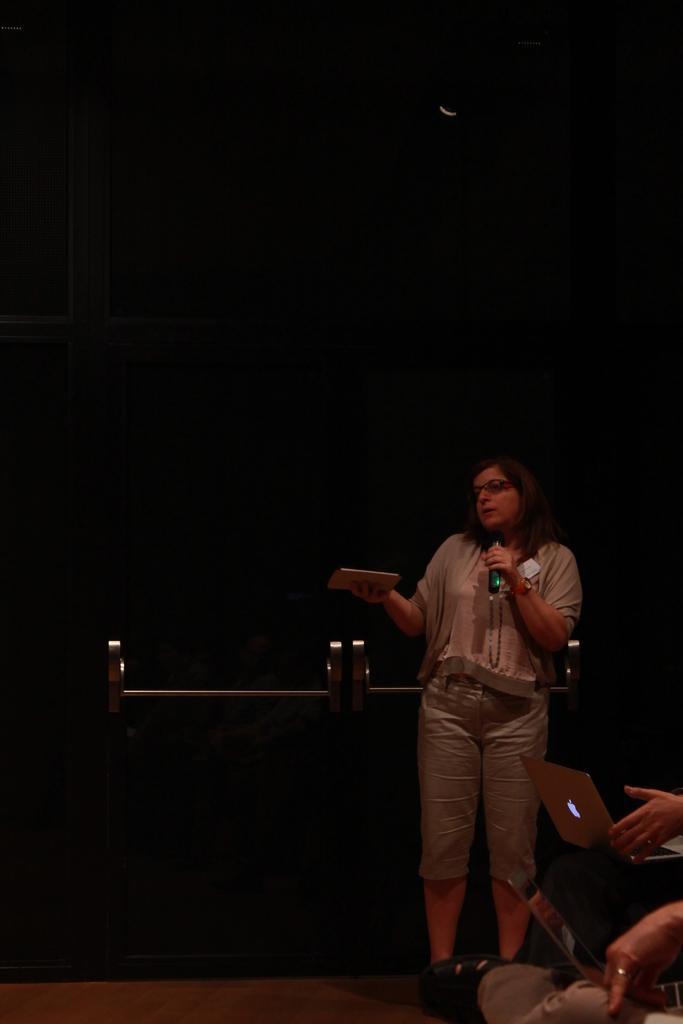In one or two sentences, can you explain what this image depicts? In this image we can see a woman holding the mike and also an object and standing. We can see the people with the laptops. We can see the floor, rods and also the black color wall. 